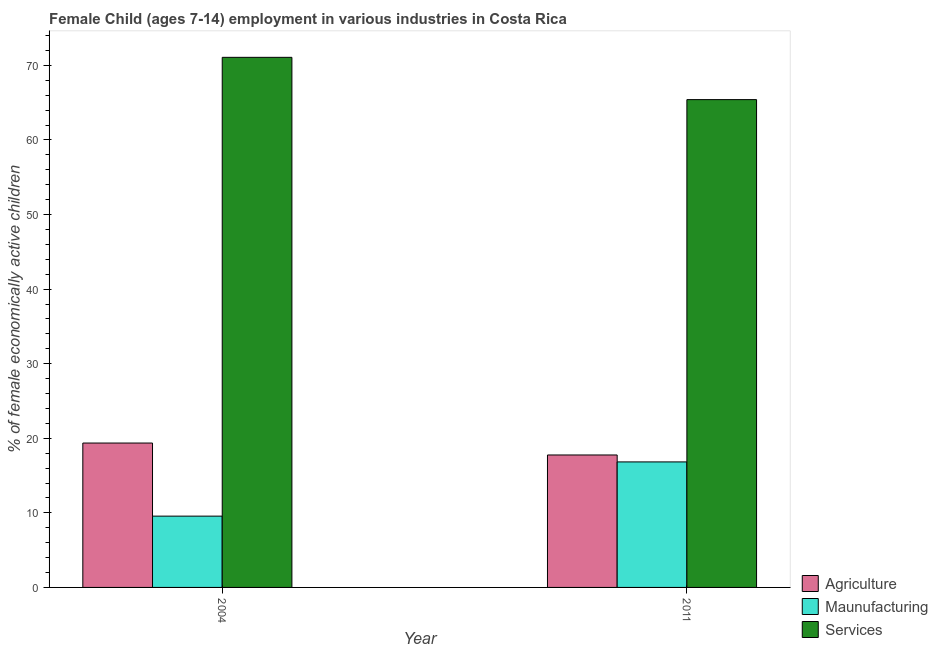What is the percentage of economically active children in services in 2004?
Provide a succinct answer. 71.08. Across all years, what is the maximum percentage of economically active children in agriculture?
Ensure brevity in your answer.  19.36. Across all years, what is the minimum percentage of economically active children in manufacturing?
Give a very brief answer. 9.56. In which year was the percentage of economically active children in manufacturing maximum?
Keep it short and to the point. 2011. In which year was the percentage of economically active children in manufacturing minimum?
Ensure brevity in your answer.  2004. What is the total percentage of economically active children in services in the graph?
Provide a short and direct response. 136.49. What is the difference between the percentage of economically active children in services in 2004 and that in 2011?
Provide a short and direct response. 5.67. What is the difference between the percentage of economically active children in manufacturing in 2011 and the percentage of economically active children in services in 2004?
Offer a very short reply. 7.27. What is the average percentage of economically active children in services per year?
Offer a very short reply. 68.25. In the year 2004, what is the difference between the percentage of economically active children in agriculture and percentage of economically active children in services?
Your answer should be compact. 0. In how many years, is the percentage of economically active children in services greater than 40 %?
Keep it short and to the point. 2. What is the ratio of the percentage of economically active children in agriculture in 2004 to that in 2011?
Provide a succinct answer. 1.09. In how many years, is the percentage of economically active children in agriculture greater than the average percentage of economically active children in agriculture taken over all years?
Offer a terse response. 1. What does the 2nd bar from the left in 2004 represents?
Your answer should be very brief. Maunufacturing. What does the 3rd bar from the right in 2011 represents?
Ensure brevity in your answer.  Agriculture. What is the difference between two consecutive major ticks on the Y-axis?
Make the answer very short. 10. Where does the legend appear in the graph?
Provide a succinct answer. Bottom right. How many legend labels are there?
Your answer should be compact. 3. How are the legend labels stacked?
Give a very brief answer. Vertical. What is the title of the graph?
Give a very brief answer. Female Child (ages 7-14) employment in various industries in Costa Rica. Does "Gaseous fuel" appear as one of the legend labels in the graph?
Provide a short and direct response. No. What is the label or title of the X-axis?
Offer a very short reply. Year. What is the label or title of the Y-axis?
Provide a short and direct response. % of female economically active children. What is the % of female economically active children of Agriculture in 2004?
Your response must be concise. 19.36. What is the % of female economically active children of Maunufacturing in 2004?
Your answer should be compact. 9.56. What is the % of female economically active children in Services in 2004?
Provide a succinct answer. 71.08. What is the % of female economically active children of Agriculture in 2011?
Ensure brevity in your answer.  17.76. What is the % of female economically active children of Maunufacturing in 2011?
Your answer should be compact. 16.83. What is the % of female economically active children of Services in 2011?
Give a very brief answer. 65.41. Across all years, what is the maximum % of female economically active children in Agriculture?
Offer a terse response. 19.36. Across all years, what is the maximum % of female economically active children of Maunufacturing?
Keep it short and to the point. 16.83. Across all years, what is the maximum % of female economically active children in Services?
Make the answer very short. 71.08. Across all years, what is the minimum % of female economically active children in Agriculture?
Keep it short and to the point. 17.76. Across all years, what is the minimum % of female economically active children of Maunufacturing?
Make the answer very short. 9.56. Across all years, what is the minimum % of female economically active children in Services?
Make the answer very short. 65.41. What is the total % of female economically active children in Agriculture in the graph?
Keep it short and to the point. 37.12. What is the total % of female economically active children in Maunufacturing in the graph?
Your answer should be compact. 26.39. What is the total % of female economically active children in Services in the graph?
Make the answer very short. 136.49. What is the difference between the % of female economically active children of Agriculture in 2004 and that in 2011?
Make the answer very short. 1.6. What is the difference between the % of female economically active children in Maunufacturing in 2004 and that in 2011?
Ensure brevity in your answer.  -7.27. What is the difference between the % of female economically active children in Services in 2004 and that in 2011?
Your answer should be very brief. 5.67. What is the difference between the % of female economically active children of Agriculture in 2004 and the % of female economically active children of Maunufacturing in 2011?
Your response must be concise. 2.53. What is the difference between the % of female economically active children of Agriculture in 2004 and the % of female economically active children of Services in 2011?
Your response must be concise. -46.05. What is the difference between the % of female economically active children in Maunufacturing in 2004 and the % of female economically active children in Services in 2011?
Your answer should be very brief. -55.85. What is the average % of female economically active children in Agriculture per year?
Ensure brevity in your answer.  18.56. What is the average % of female economically active children in Maunufacturing per year?
Offer a terse response. 13.2. What is the average % of female economically active children in Services per year?
Your answer should be compact. 68.25. In the year 2004, what is the difference between the % of female economically active children of Agriculture and % of female economically active children of Maunufacturing?
Your response must be concise. 9.8. In the year 2004, what is the difference between the % of female economically active children of Agriculture and % of female economically active children of Services?
Provide a succinct answer. -51.72. In the year 2004, what is the difference between the % of female economically active children in Maunufacturing and % of female economically active children in Services?
Offer a very short reply. -61.52. In the year 2011, what is the difference between the % of female economically active children of Agriculture and % of female economically active children of Maunufacturing?
Provide a succinct answer. 0.93. In the year 2011, what is the difference between the % of female economically active children of Agriculture and % of female economically active children of Services?
Your answer should be very brief. -47.65. In the year 2011, what is the difference between the % of female economically active children of Maunufacturing and % of female economically active children of Services?
Give a very brief answer. -48.58. What is the ratio of the % of female economically active children in Agriculture in 2004 to that in 2011?
Your response must be concise. 1.09. What is the ratio of the % of female economically active children of Maunufacturing in 2004 to that in 2011?
Offer a terse response. 0.57. What is the ratio of the % of female economically active children of Services in 2004 to that in 2011?
Give a very brief answer. 1.09. What is the difference between the highest and the second highest % of female economically active children in Maunufacturing?
Offer a very short reply. 7.27. What is the difference between the highest and the second highest % of female economically active children in Services?
Provide a short and direct response. 5.67. What is the difference between the highest and the lowest % of female economically active children of Agriculture?
Your answer should be compact. 1.6. What is the difference between the highest and the lowest % of female economically active children in Maunufacturing?
Offer a terse response. 7.27. What is the difference between the highest and the lowest % of female economically active children in Services?
Offer a very short reply. 5.67. 